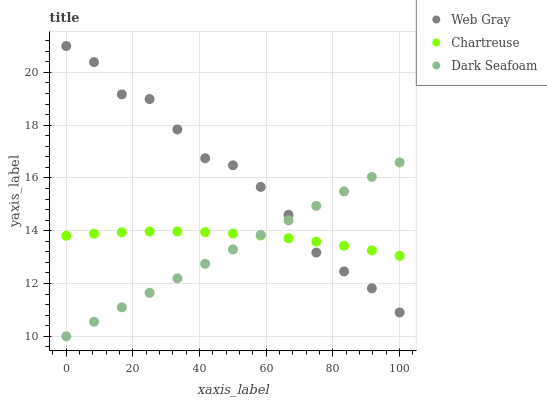Does Dark Seafoam have the minimum area under the curve?
Answer yes or no. Yes. Does Web Gray have the maximum area under the curve?
Answer yes or no. Yes. Does Web Gray have the minimum area under the curve?
Answer yes or no. No. Does Dark Seafoam have the maximum area under the curve?
Answer yes or no. No. Is Dark Seafoam the smoothest?
Answer yes or no. Yes. Is Web Gray the roughest?
Answer yes or no. Yes. Is Web Gray the smoothest?
Answer yes or no. No. Is Dark Seafoam the roughest?
Answer yes or no. No. Does Dark Seafoam have the lowest value?
Answer yes or no. Yes. Does Web Gray have the lowest value?
Answer yes or no. No. Does Web Gray have the highest value?
Answer yes or no. Yes. Does Dark Seafoam have the highest value?
Answer yes or no. No. Does Dark Seafoam intersect Web Gray?
Answer yes or no. Yes. Is Dark Seafoam less than Web Gray?
Answer yes or no. No. Is Dark Seafoam greater than Web Gray?
Answer yes or no. No. 